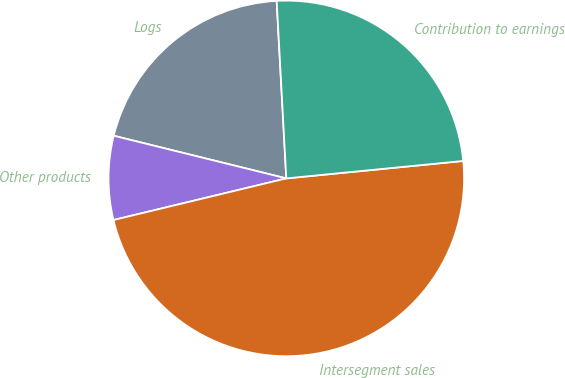Convert chart to OTSL. <chart><loc_0><loc_0><loc_500><loc_500><pie_chart><fcel>Logs<fcel>Other products<fcel>Intersegment sales<fcel>Contribution to earnings<nl><fcel>20.28%<fcel>7.62%<fcel>47.8%<fcel>24.3%<nl></chart> 